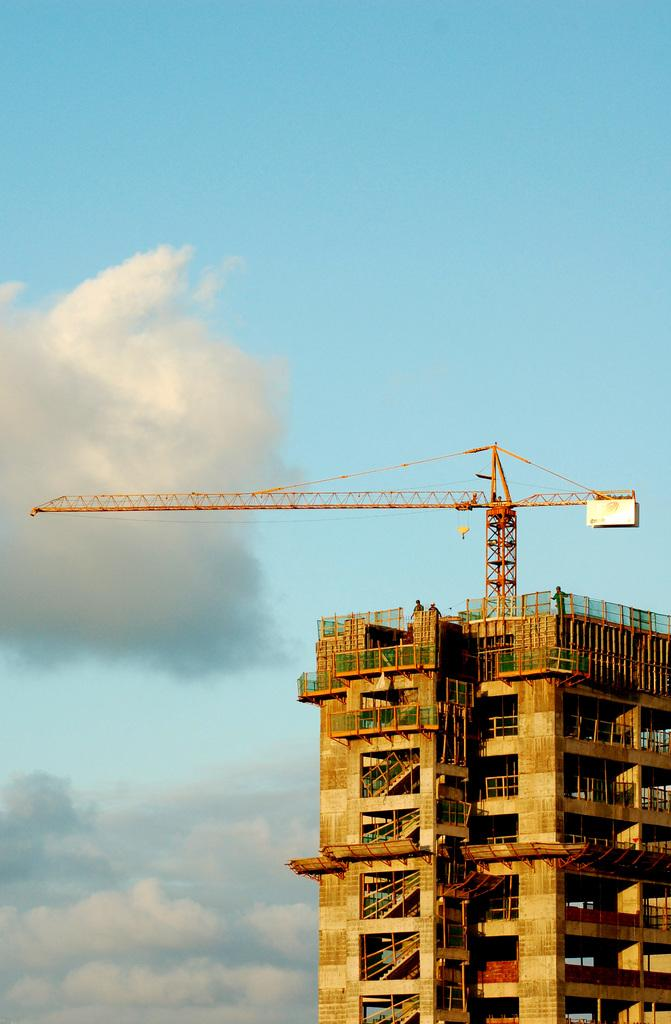What can be seen in the background of the image? The sky is visible in the image. What is the condition of the sky in the image? The sky is cloudy in the image. What type of structure is present in the image? There is a constructed building in the image. Can you tell me how many books are in the library in the image? There is no library present in the image, so it is not possible to determine the number of books. 